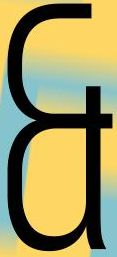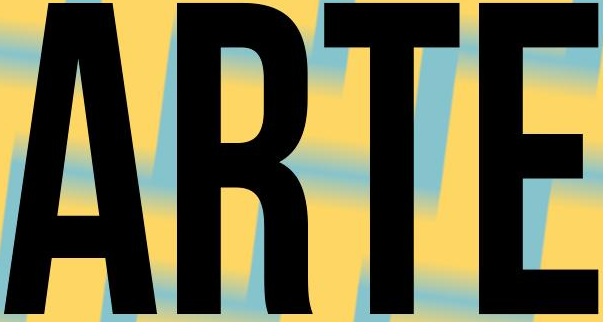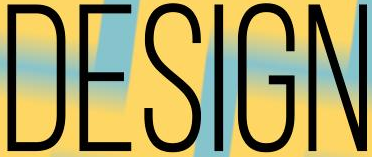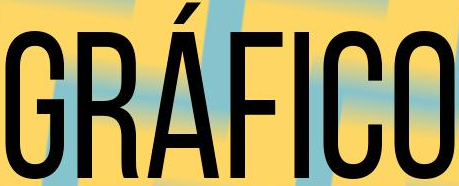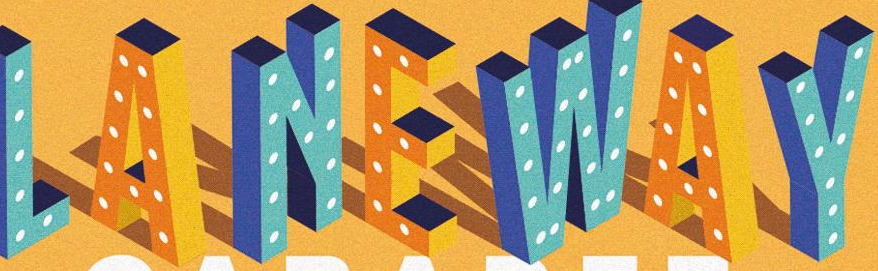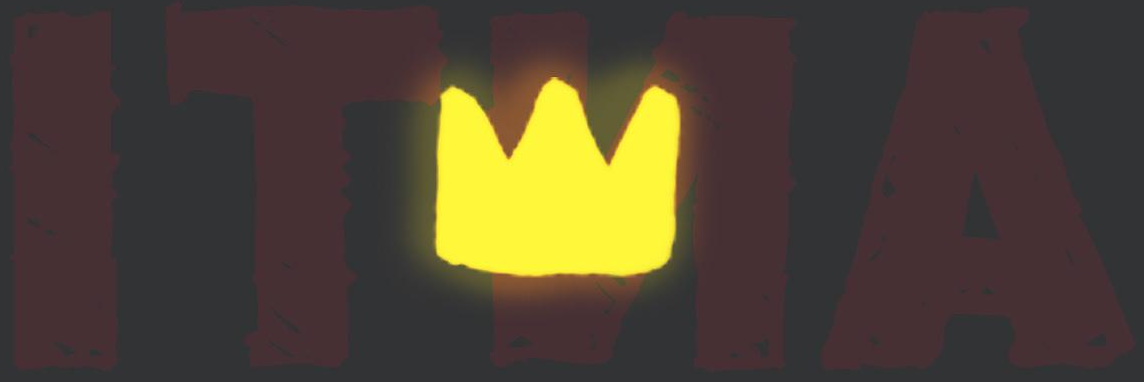What words are shown in these images in order, separated by a semicolon? &; ARTE; DESIGN; GRÁFICO; LANEWAY; ITNA 